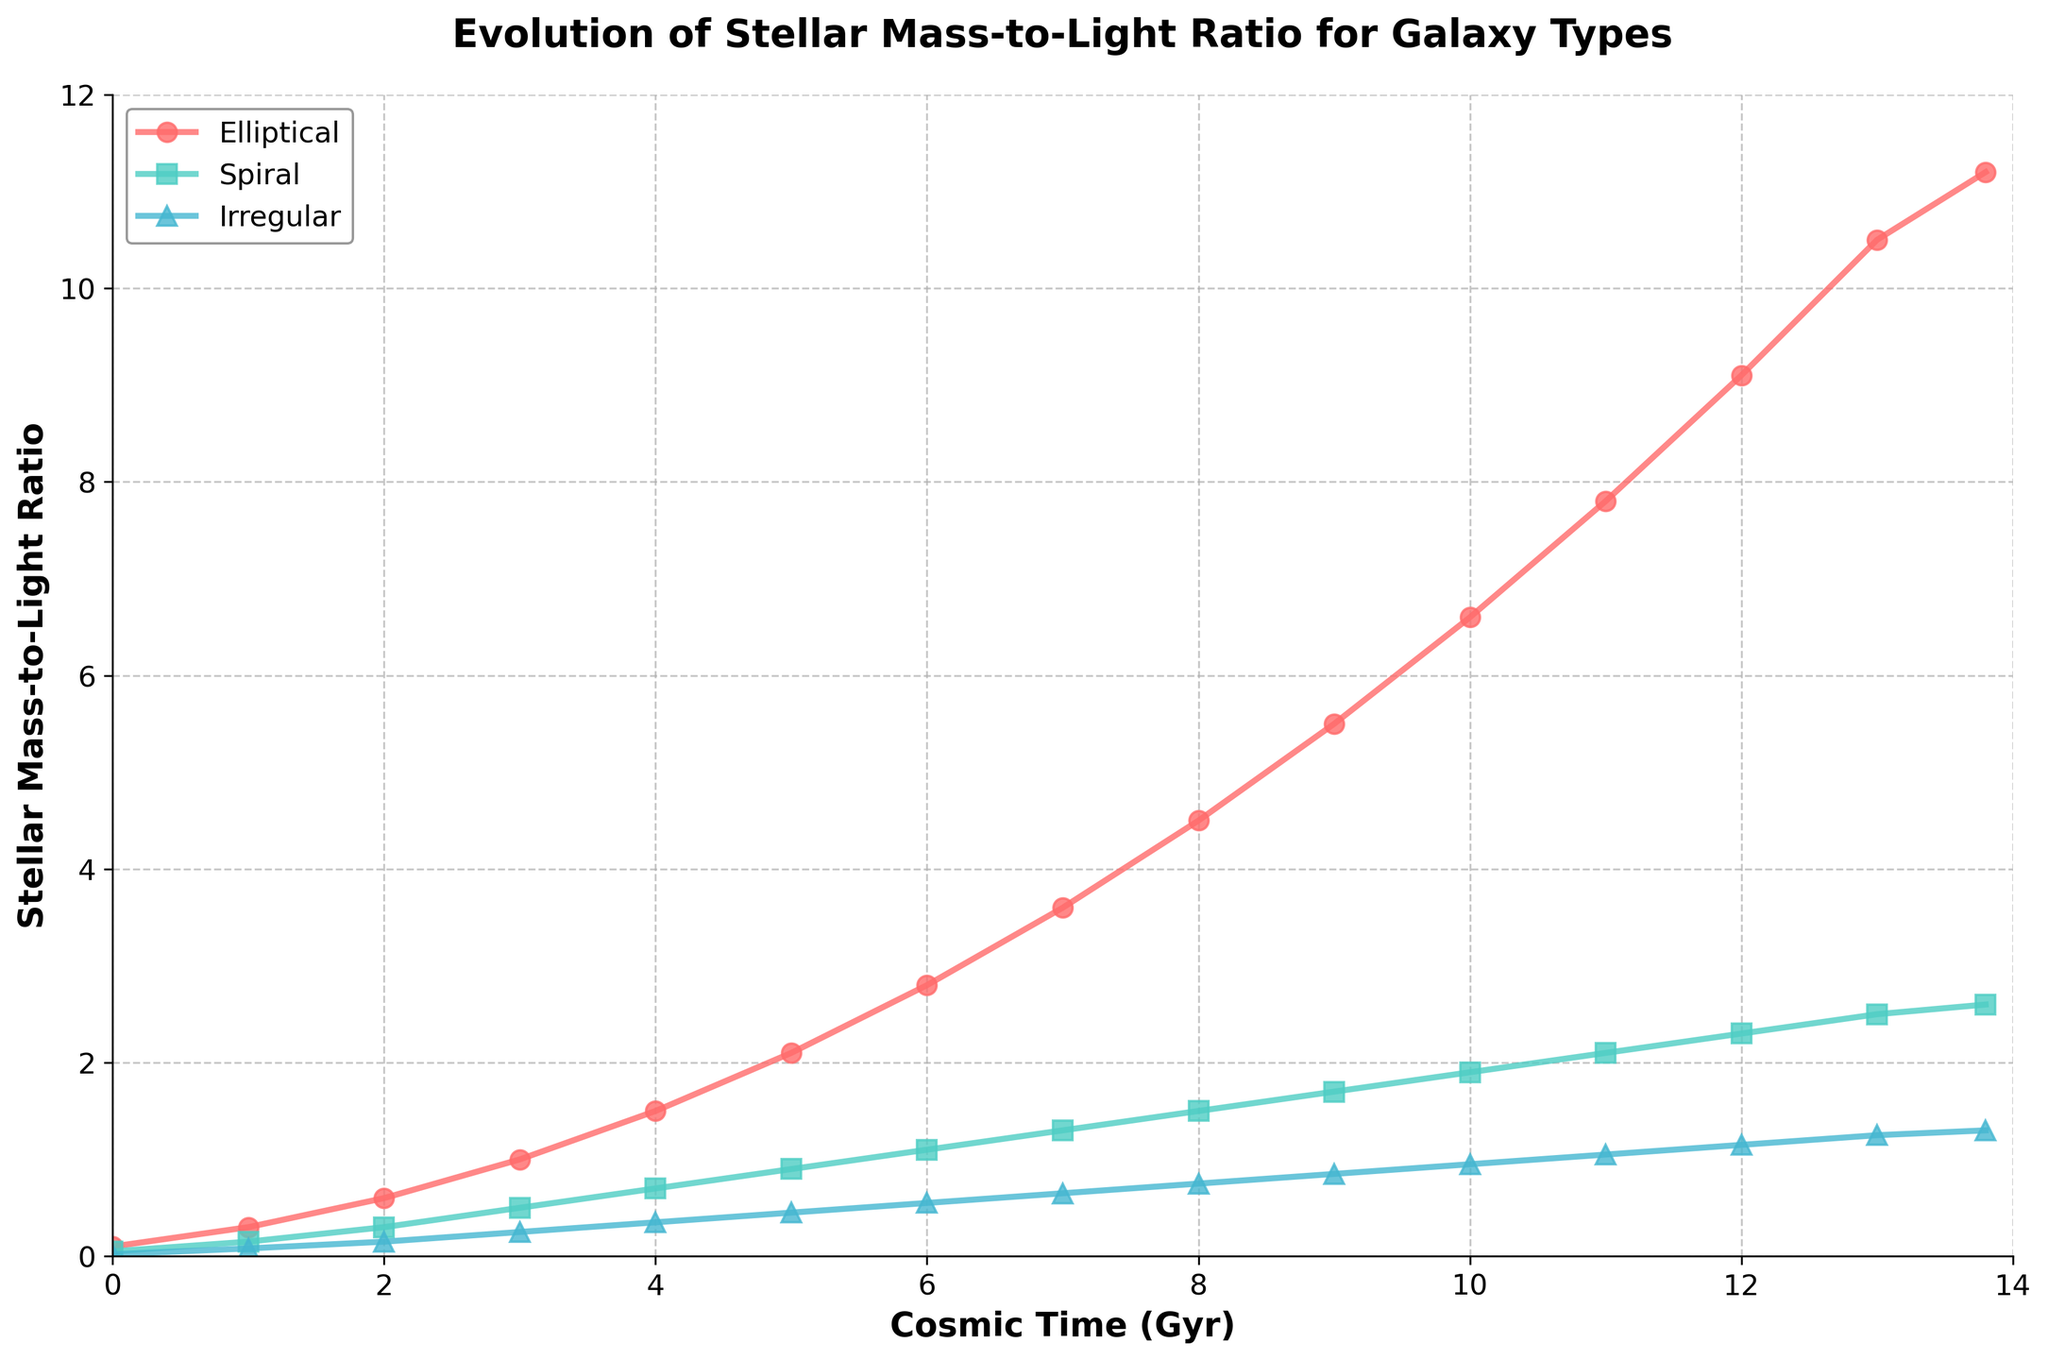Which galaxy type shows the highest Stellar Mass-to-Light ratio at 10 Gyr? By evaluating the values at 10 Gyr, the Elliptical galaxy type has the highest ratio of 6.6.
Answer: Elliptical How does the Stellar Mass-to-Light ratio for Spiral galaxies at 5 Gyr compare to that for Irregular galaxies at 10 Gyr? Comparing the values, Spiral galaxies have a ratio of 0.9 at 5 Gyr, whereas Irregular galaxies have a ratio of 0.95 at 10 Gyr, making the Irregular ratio higher.
Answer: Irregular higher What is the average Stellar Mass-to-Light ratio for Elliptical galaxies between 2 Gyr and 6 Gyr? Summing up the values for Elliptical galaxies (0.6, 1.0, 1.5, 2.1, 2.8) and dividing by 5 gives (0.6 + 1.0 + 1.5 + 2.1 + 2.8) / 5 = 8 / 5 = 1.6.
Answer: 1.6 Which galaxy type has the steepest increase in Stellar Mass-to-Light ratio between 0 Gyr and 3 Gyr? By observing the change from 0 to 3 Gyr: Elliptical (0.1 to 1.0, 0.9 increase), Spiral (0.05 to 0.5, 0.45 increase), Irregular (0.02 to 0.25, 0.23 increase). The Elliptical type increases the most.
Answer: Elliptical At what cosmic time does the Stellar Mass-to-Light ratio for Elliptical galaxies reach 4.5? From the visual plot, the Elliptical galaxies reach a ratio of 4.5 at 8 Gyr.
Answer: 8 Gyr What is the difference in Stellar Mass-to-Light ratio between Elliptical and Spiral galaxies at 12 Gyr? Subtracting the values at 12 Gyr for Elliptical (9.1) and Spiral (2.3) gives 9.1 - 2.3 = 6.8.
Answer: 6.8 Between 7 Gyr and 9 Gyr, how much does the Stellar Mass-to-Light ratio for Irregular galaxies increase? The increase can be calculated by subtracting the value at 7 Gyr (0.65) from the value at 9 Gyr (0.85), resulting in 0.85 - 0.65 = 0.2.
Answer: 0.2 Which galaxy type's ratio remains below 1.0 the longest? Observing the plotted data, the Spiral galaxies' ratio stays below 1.0 up until 5 Gyr, while other types exceed 1.0 earlier.
Answer: Spiral What is the combined Stellar Mass-to-Light ratio of all galaxy types at 13.8 Gyr? Adding the values for Elliptical (11.2), Spiral (2.6), and Irregular (1.3) gives 11.2 + 2.6 + 1.3 = 15.1.
Answer: 15.1 Among all galaxy types, which one shows the smallest increase in Stellar Mass-to-Light ratio from 0 to 13.8 Gyr? Calculating the increase for each: Elliptical (11.2 - 0.1 = 11.1), Spiral (2.6 - 0.05 = 2.55), Irregular (1.3 - 0.02 = 1.28). The Irregular galaxies show the smallest increase.
Answer: Irregular 